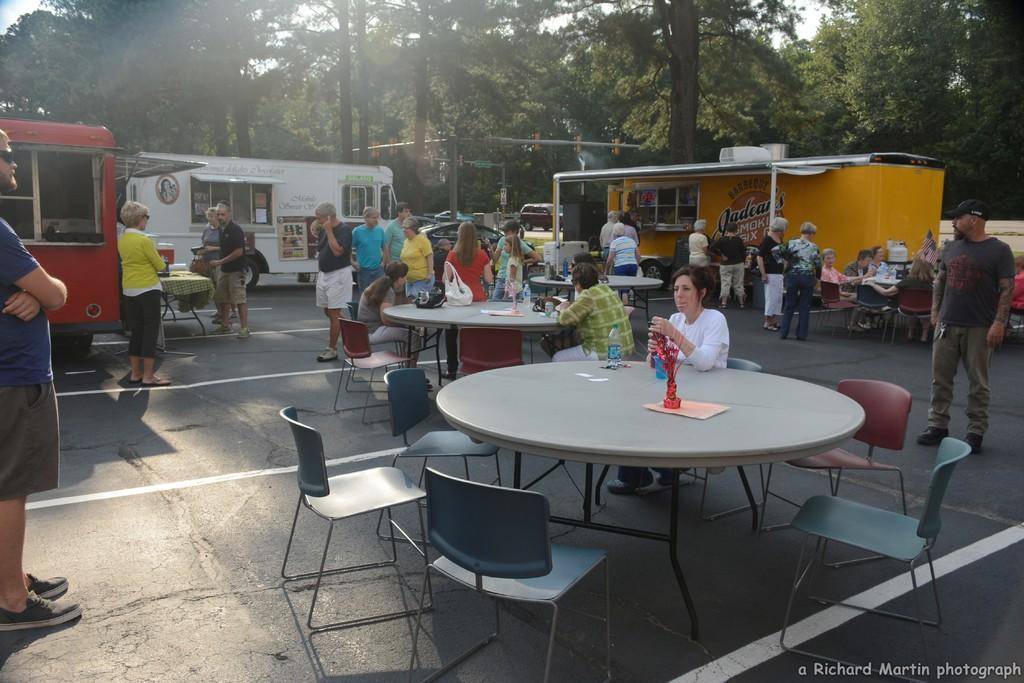What is happening on the road in the image? There is a crowd of people standing on a road in the image. What type of vehicles can be seen in the image? There are three food trucks in the image. What furniture is present in the image? Tables and chairs are present in the image. What can be seen in the background of the image? There are trees visible on the other side of the image. What type of pear is being sold at the selection in the shop in the image? There is no pear or shop present in the image. 